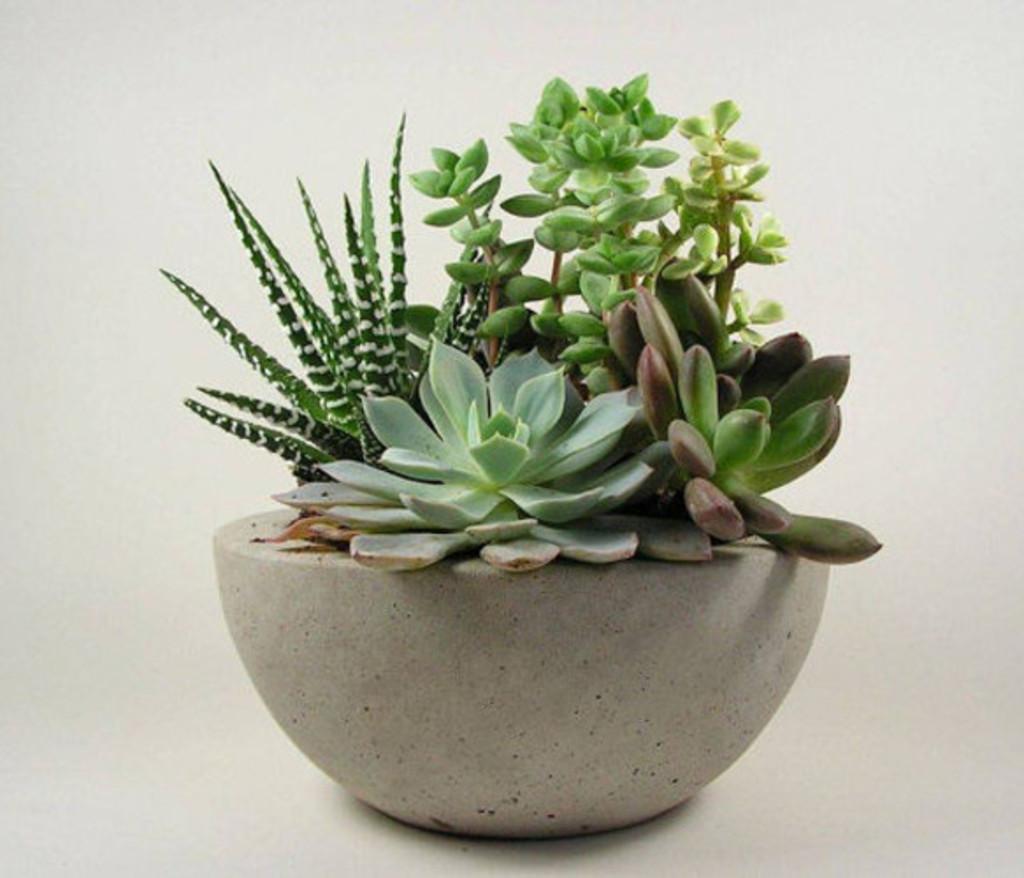In one or two sentences, can you explain what this image depicts? In the image there is a plant pot on the floor. 